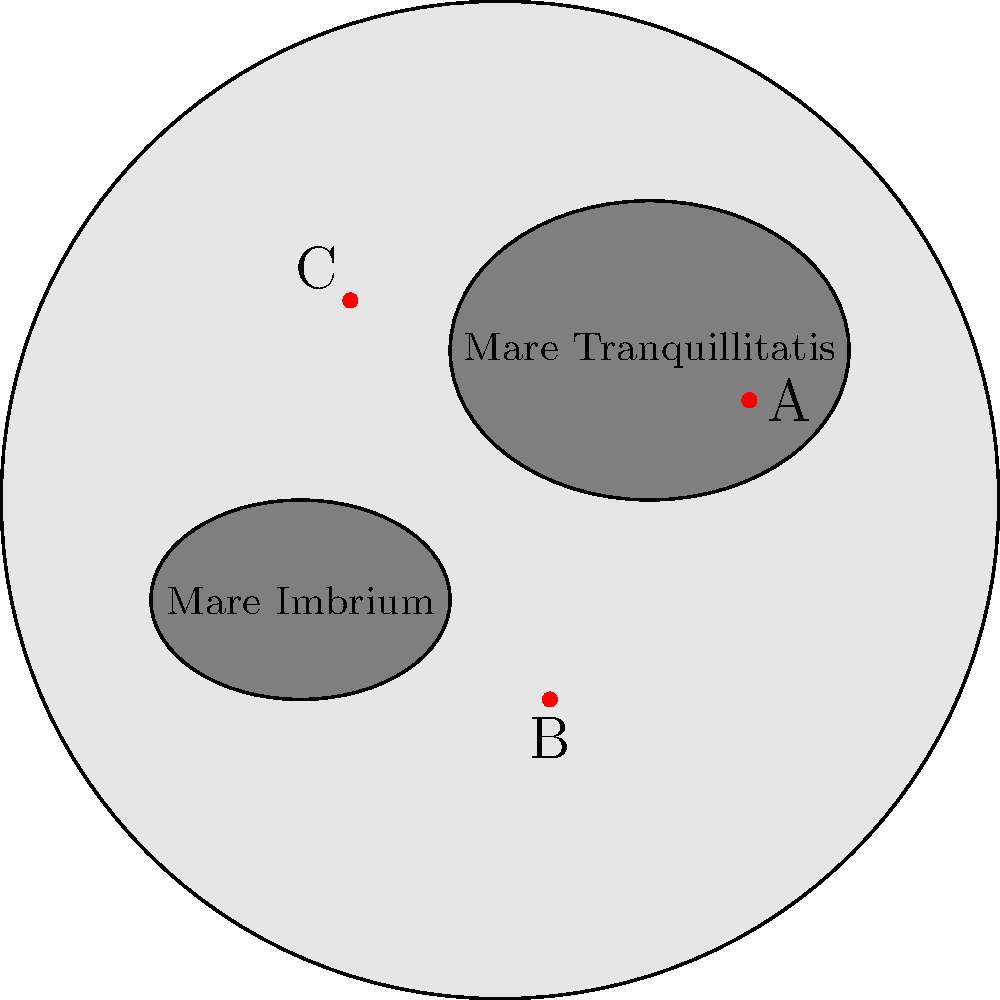The image shows a simplified map of the Moon's surface with three Apollo mission landing sites marked as A, B, and C. Which of these sites corresponds to the historic Apollo 11 mission, where humans first set foot on the Moon? To answer this question, we need to consider the following steps:

1. Recall that Apollo 11 was the first mission to land humans on the Moon.
2. The landing site for Apollo 11 was carefully chosen to be in a relatively flat and safe area.
3. The chosen location was in the Mare Tranquillitatis (Sea of Tranquility).
4. Looking at the map:
   - Site A is located in the Mare Tranquillitatis.
   - Site B is in the southern region, not in a mare.
   - Site C is in the northern region, near the edge of a mare.
5. Based on this information, we can conclude that Site A corresponds to the Apollo 11 landing site.

Additional information:
- Site B likely represents Apollo 14's landing site in the Fra Mauro formation.
- Site C could represent Apollo 15's landing site near Hadley Rille, at the edge of Mare Imbrium.

It's important to note that this is a simplified representation, and actual landing sites were chosen based on much more detailed geological and topographical data.
Answer: Site A 